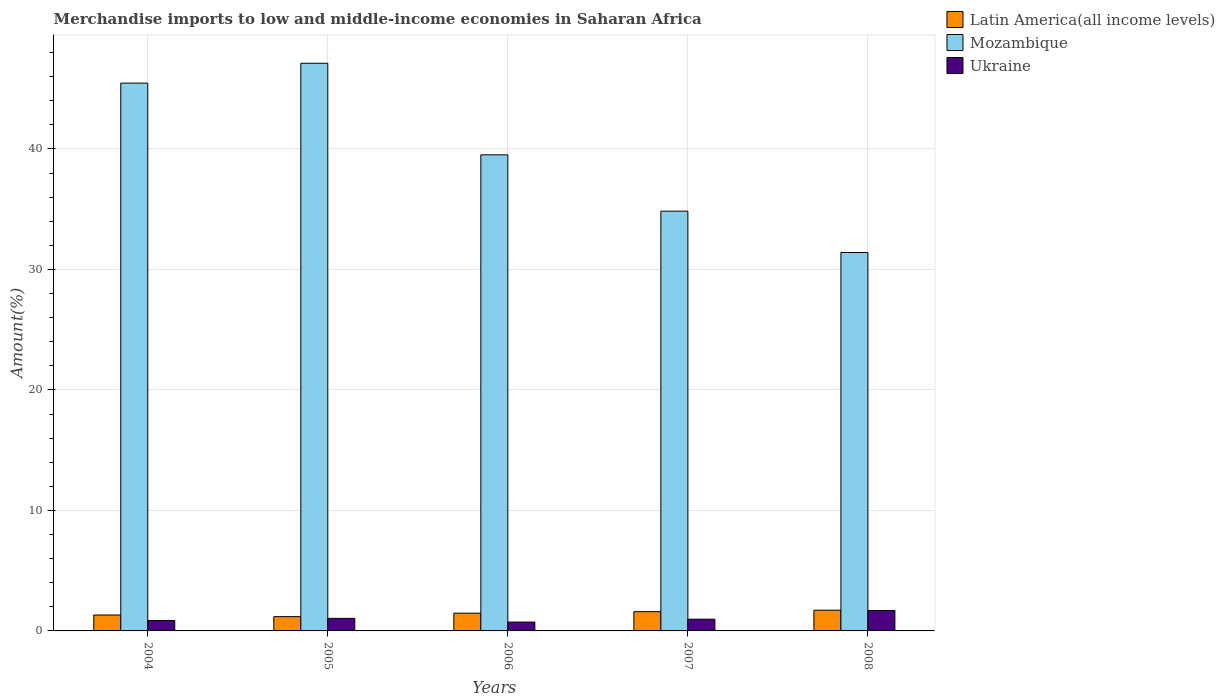How many groups of bars are there?
Provide a short and direct response. 5. Are the number of bars per tick equal to the number of legend labels?
Your answer should be very brief. Yes. Are the number of bars on each tick of the X-axis equal?
Your answer should be compact. Yes. What is the label of the 4th group of bars from the left?
Your answer should be very brief. 2007. In how many cases, is the number of bars for a given year not equal to the number of legend labels?
Your answer should be compact. 0. What is the percentage of amount earned from merchandise imports in Mozambique in 2005?
Give a very brief answer. 47.11. Across all years, what is the maximum percentage of amount earned from merchandise imports in Latin America(all income levels)?
Make the answer very short. 1.72. Across all years, what is the minimum percentage of amount earned from merchandise imports in Latin America(all income levels)?
Give a very brief answer. 1.18. In which year was the percentage of amount earned from merchandise imports in Ukraine maximum?
Give a very brief answer. 2008. In which year was the percentage of amount earned from merchandise imports in Mozambique minimum?
Offer a very short reply. 2008. What is the total percentage of amount earned from merchandise imports in Mozambique in the graph?
Make the answer very short. 198.34. What is the difference between the percentage of amount earned from merchandise imports in Mozambique in 2006 and that in 2007?
Provide a short and direct response. 4.67. What is the difference between the percentage of amount earned from merchandise imports in Latin America(all income levels) in 2005 and the percentage of amount earned from merchandise imports in Mozambique in 2006?
Provide a short and direct response. -38.33. What is the average percentage of amount earned from merchandise imports in Ukraine per year?
Provide a short and direct response. 1.06. In the year 2007, what is the difference between the percentage of amount earned from merchandise imports in Ukraine and percentage of amount earned from merchandise imports in Mozambique?
Give a very brief answer. -33.86. In how many years, is the percentage of amount earned from merchandise imports in Ukraine greater than 16 %?
Make the answer very short. 0. What is the ratio of the percentage of amount earned from merchandise imports in Ukraine in 2004 to that in 2006?
Offer a terse response. 1.17. Is the percentage of amount earned from merchandise imports in Ukraine in 2005 less than that in 2008?
Keep it short and to the point. Yes. What is the difference between the highest and the second highest percentage of amount earned from merchandise imports in Mozambique?
Provide a succinct answer. 1.65. What is the difference between the highest and the lowest percentage of amount earned from merchandise imports in Ukraine?
Offer a very short reply. 0.96. What does the 1st bar from the left in 2008 represents?
Give a very brief answer. Latin America(all income levels). What does the 3rd bar from the right in 2004 represents?
Keep it short and to the point. Latin America(all income levels). Is it the case that in every year, the sum of the percentage of amount earned from merchandise imports in Latin America(all income levels) and percentage of amount earned from merchandise imports in Ukraine is greater than the percentage of amount earned from merchandise imports in Mozambique?
Offer a terse response. No. How many bars are there?
Provide a succinct answer. 15. Are all the bars in the graph horizontal?
Provide a short and direct response. No. How many years are there in the graph?
Keep it short and to the point. 5. Are the values on the major ticks of Y-axis written in scientific E-notation?
Your answer should be very brief. No. Does the graph contain grids?
Make the answer very short. Yes. Where does the legend appear in the graph?
Your response must be concise. Top right. How many legend labels are there?
Offer a very short reply. 3. How are the legend labels stacked?
Provide a short and direct response. Vertical. What is the title of the graph?
Offer a very short reply. Merchandise imports to low and middle-income economies in Saharan Africa. What is the label or title of the Y-axis?
Your answer should be compact. Amount(%). What is the Amount(%) in Latin America(all income levels) in 2004?
Your answer should be compact. 1.32. What is the Amount(%) in Mozambique in 2004?
Provide a short and direct response. 45.47. What is the Amount(%) of Ukraine in 2004?
Offer a very short reply. 0.86. What is the Amount(%) of Latin America(all income levels) in 2005?
Provide a succinct answer. 1.18. What is the Amount(%) of Mozambique in 2005?
Your response must be concise. 47.11. What is the Amount(%) in Ukraine in 2005?
Provide a succinct answer. 1.04. What is the Amount(%) of Latin America(all income levels) in 2006?
Your answer should be compact. 1.47. What is the Amount(%) of Mozambique in 2006?
Make the answer very short. 39.51. What is the Amount(%) of Ukraine in 2006?
Offer a very short reply. 0.74. What is the Amount(%) of Latin America(all income levels) in 2007?
Provide a short and direct response. 1.6. What is the Amount(%) in Mozambique in 2007?
Give a very brief answer. 34.84. What is the Amount(%) of Ukraine in 2007?
Make the answer very short. 0.97. What is the Amount(%) in Latin America(all income levels) in 2008?
Your answer should be very brief. 1.72. What is the Amount(%) of Mozambique in 2008?
Your answer should be compact. 31.41. What is the Amount(%) in Ukraine in 2008?
Give a very brief answer. 1.7. Across all years, what is the maximum Amount(%) of Latin America(all income levels)?
Provide a succinct answer. 1.72. Across all years, what is the maximum Amount(%) of Mozambique?
Offer a terse response. 47.11. Across all years, what is the maximum Amount(%) in Ukraine?
Ensure brevity in your answer.  1.7. Across all years, what is the minimum Amount(%) of Latin America(all income levels)?
Give a very brief answer. 1.18. Across all years, what is the minimum Amount(%) of Mozambique?
Provide a short and direct response. 31.41. Across all years, what is the minimum Amount(%) of Ukraine?
Offer a terse response. 0.74. What is the total Amount(%) of Latin America(all income levels) in the graph?
Offer a terse response. 7.3. What is the total Amount(%) of Mozambique in the graph?
Make the answer very short. 198.34. What is the total Amount(%) of Ukraine in the graph?
Offer a very short reply. 5.31. What is the difference between the Amount(%) in Latin America(all income levels) in 2004 and that in 2005?
Keep it short and to the point. 0.14. What is the difference between the Amount(%) of Mozambique in 2004 and that in 2005?
Give a very brief answer. -1.65. What is the difference between the Amount(%) in Ukraine in 2004 and that in 2005?
Your answer should be compact. -0.18. What is the difference between the Amount(%) in Latin America(all income levels) in 2004 and that in 2006?
Offer a very short reply. -0.15. What is the difference between the Amount(%) in Mozambique in 2004 and that in 2006?
Your answer should be very brief. 5.95. What is the difference between the Amount(%) in Ukraine in 2004 and that in 2006?
Give a very brief answer. 0.13. What is the difference between the Amount(%) of Latin America(all income levels) in 2004 and that in 2007?
Keep it short and to the point. -0.28. What is the difference between the Amount(%) in Mozambique in 2004 and that in 2007?
Give a very brief answer. 10.63. What is the difference between the Amount(%) of Ukraine in 2004 and that in 2007?
Keep it short and to the point. -0.11. What is the difference between the Amount(%) of Latin America(all income levels) in 2004 and that in 2008?
Provide a short and direct response. -0.4. What is the difference between the Amount(%) of Mozambique in 2004 and that in 2008?
Provide a succinct answer. 14.06. What is the difference between the Amount(%) of Ukraine in 2004 and that in 2008?
Offer a very short reply. -0.83. What is the difference between the Amount(%) in Latin America(all income levels) in 2005 and that in 2006?
Ensure brevity in your answer.  -0.29. What is the difference between the Amount(%) of Mozambique in 2005 and that in 2006?
Offer a terse response. 7.6. What is the difference between the Amount(%) in Ukraine in 2005 and that in 2006?
Offer a terse response. 0.31. What is the difference between the Amount(%) of Latin America(all income levels) in 2005 and that in 2007?
Your answer should be very brief. -0.41. What is the difference between the Amount(%) in Mozambique in 2005 and that in 2007?
Keep it short and to the point. 12.27. What is the difference between the Amount(%) of Ukraine in 2005 and that in 2007?
Keep it short and to the point. 0.07. What is the difference between the Amount(%) of Latin America(all income levels) in 2005 and that in 2008?
Provide a succinct answer. -0.53. What is the difference between the Amount(%) of Mozambique in 2005 and that in 2008?
Make the answer very short. 15.71. What is the difference between the Amount(%) in Ukraine in 2005 and that in 2008?
Your answer should be very brief. -0.65. What is the difference between the Amount(%) of Latin America(all income levels) in 2006 and that in 2007?
Offer a terse response. -0.12. What is the difference between the Amount(%) in Mozambique in 2006 and that in 2007?
Your answer should be compact. 4.67. What is the difference between the Amount(%) of Ukraine in 2006 and that in 2007?
Offer a terse response. -0.24. What is the difference between the Amount(%) of Latin America(all income levels) in 2006 and that in 2008?
Provide a succinct answer. -0.24. What is the difference between the Amount(%) of Mozambique in 2006 and that in 2008?
Ensure brevity in your answer.  8.11. What is the difference between the Amount(%) in Ukraine in 2006 and that in 2008?
Offer a very short reply. -0.96. What is the difference between the Amount(%) of Latin America(all income levels) in 2007 and that in 2008?
Your answer should be very brief. -0.12. What is the difference between the Amount(%) in Mozambique in 2007 and that in 2008?
Your answer should be very brief. 3.43. What is the difference between the Amount(%) of Ukraine in 2007 and that in 2008?
Offer a very short reply. -0.72. What is the difference between the Amount(%) of Latin America(all income levels) in 2004 and the Amount(%) of Mozambique in 2005?
Your answer should be compact. -45.79. What is the difference between the Amount(%) of Latin America(all income levels) in 2004 and the Amount(%) of Ukraine in 2005?
Ensure brevity in your answer.  0.28. What is the difference between the Amount(%) of Mozambique in 2004 and the Amount(%) of Ukraine in 2005?
Provide a short and direct response. 44.42. What is the difference between the Amount(%) of Latin America(all income levels) in 2004 and the Amount(%) of Mozambique in 2006?
Your answer should be compact. -38.19. What is the difference between the Amount(%) of Latin America(all income levels) in 2004 and the Amount(%) of Ukraine in 2006?
Your answer should be very brief. 0.59. What is the difference between the Amount(%) of Mozambique in 2004 and the Amount(%) of Ukraine in 2006?
Offer a terse response. 44.73. What is the difference between the Amount(%) of Latin America(all income levels) in 2004 and the Amount(%) of Mozambique in 2007?
Make the answer very short. -33.52. What is the difference between the Amount(%) of Latin America(all income levels) in 2004 and the Amount(%) of Ukraine in 2007?
Offer a terse response. 0.35. What is the difference between the Amount(%) in Mozambique in 2004 and the Amount(%) in Ukraine in 2007?
Ensure brevity in your answer.  44.49. What is the difference between the Amount(%) of Latin America(all income levels) in 2004 and the Amount(%) of Mozambique in 2008?
Your answer should be compact. -30.08. What is the difference between the Amount(%) in Latin America(all income levels) in 2004 and the Amount(%) in Ukraine in 2008?
Your answer should be compact. -0.37. What is the difference between the Amount(%) in Mozambique in 2004 and the Amount(%) in Ukraine in 2008?
Your response must be concise. 43.77. What is the difference between the Amount(%) in Latin America(all income levels) in 2005 and the Amount(%) in Mozambique in 2006?
Make the answer very short. -38.33. What is the difference between the Amount(%) of Latin America(all income levels) in 2005 and the Amount(%) of Ukraine in 2006?
Make the answer very short. 0.45. What is the difference between the Amount(%) of Mozambique in 2005 and the Amount(%) of Ukraine in 2006?
Offer a terse response. 46.38. What is the difference between the Amount(%) in Latin America(all income levels) in 2005 and the Amount(%) in Mozambique in 2007?
Offer a terse response. -33.65. What is the difference between the Amount(%) of Latin America(all income levels) in 2005 and the Amount(%) of Ukraine in 2007?
Provide a short and direct response. 0.21. What is the difference between the Amount(%) of Mozambique in 2005 and the Amount(%) of Ukraine in 2007?
Provide a succinct answer. 46.14. What is the difference between the Amount(%) in Latin America(all income levels) in 2005 and the Amount(%) in Mozambique in 2008?
Your answer should be very brief. -30.22. What is the difference between the Amount(%) in Latin America(all income levels) in 2005 and the Amount(%) in Ukraine in 2008?
Give a very brief answer. -0.51. What is the difference between the Amount(%) of Mozambique in 2005 and the Amount(%) of Ukraine in 2008?
Your answer should be compact. 45.42. What is the difference between the Amount(%) of Latin America(all income levels) in 2006 and the Amount(%) of Mozambique in 2007?
Keep it short and to the point. -33.36. What is the difference between the Amount(%) of Latin America(all income levels) in 2006 and the Amount(%) of Ukraine in 2007?
Keep it short and to the point. 0.5. What is the difference between the Amount(%) of Mozambique in 2006 and the Amount(%) of Ukraine in 2007?
Give a very brief answer. 38.54. What is the difference between the Amount(%) of Latin America(all income levels) in 2006 and the Amount(%) of Mozambique in 2008?
Your answer should be compact. -29.93. What is the difference between the Amount(%) in Latin America(all income levels) in 2006 and the Amount(%) in Ukraine in 2008?
Make the answer very short. -0.22. What is the difference between the Amount(%) in Mozambique in 2006 and the Amount(%) in Ukraine in 2008?
Ensure brevity in your answer.  37.82. What is the difference between the Amount(%) in Latin America(all income levels) in 2007 and the Amount(%) in Mozambique in 2008?
Your answer should be compact. -29.81. What is the difference between the Amount(%) in Latin America(all income levels) in 2007 and the Amount(%) in Ukraine in 2008?
Offer a terse response. -0.1. What is the difference between the Amount(%) in Mozambique in 2007 and the Amount(%) in Ukraine in 2008?
Provide a succinct answer. 33.14. What is the average Amount(%) of Latin America(all income levels) per year?
Your response must be concise. 1.46. What is the average Amount(%) of Mozambique per year?
Your answer should be very brief. 39.67. What is the average Amount(%) of Ukraine per year?
Provide a short and direct response. 1.06. In the year 2004, what is the difference between the Amount(%) in Latin America(all income levels) and Amount(%) in Mozambique?
Your answer should be very brief. -44.15. In the year 2004, what is the difference between the Amount(%) of Latin America(all income levels) and Amount(%) of Ukraine?
Give a very brief answer. 0.46. In the year 2004, what is the difference between the Amount(%) of Mozambique and Amount(%) of Ukraine?
Your answer should be very brief. 44.6. In the year 2005, what is the difference between the Amount(%) of Latin America(all income levels) and Amount(%) of Mozambique?
Provide a succinct answer. -45.93. In the year 2005, what is the difference between the Amount(%) in Latin America(all income levels) and Amount(%) in Ukraine?
Keep it short and to the point. 0.14. In the year 2005, what is the difference between the Amount(%) in Mozambique and Amount(%) in Ukraine?
Ensure brevity in your answer.  46.07. In the year 2006, what is the difference between the Amount(%) of Latin America(all income levels) and Amount(%) of Mozambique?
Give a very brief answer. -38.04. In the year 2006, what is the difference between the Amount(%) of Latin America(all income levels) and Amount(%) of Ukraine?
Your response must be concise. 0.74. In the year 2006, what is the difference between the Amount(%) of Mozambique and Amount(%) of Ukraine?
Provide a succinct answer. 38.78. In the year 2007, what is the difference between the Amount(%) of Latin America(all income levels) and Amount(%) of Mozambique?
Provide a short and direct response. -33.24. In the year 2007, what is the difference between the Amount(%) of Latin America(all income levels) and Amount(%) of Ukraine?
Offer a very short reply. 0.62. In the year 2007, what is the difference between the Amount(%) of Mozambique and Amount(%) of Ukraine?
Your answer should be compact. 33.86. In the year 2008, what is the difference between the Amount(%) of Latin America(all income levels) and Amount(%) of Mozambique?
Your response must be concise. -29.69. In the year 2008, what is the difference between the Amount(%) of Latin America(all income levels) and Amount(%) of Ukraine?
Keep it short and to the point. 0.02. In the year 2008, what is the difference between the Amount(%) of Mozambique and Amount(%) of Ukraine?
Make the answer very short. 29.71. What is the ratio of the Amount(%) of Latin America(all income levels) in 2004 to that in 2005?
Provide a short and direct response. 1.12. What is the ratio of the Amount(%) in Mozambique in 2004 to that in 2005?
Offer a terse response. 0.97. What is the ratio of the Amount(%) in Ukraine in 2004 to that in 2005?
Your answer should be compact. 0.83. What is the ratio of the Amount(%) in Latin America(all income levels) in 2004 to that in 2006?
Give a very brief answer. 0.9. What is the ratio of the Amount(%) in Mozambique in 2004 to that in 2006?
Give a very brief answer. 1.15. What is the ratio of the Amount(%) in Ukraine in 2004 to that in 2006?
Ensure brevity in your answer.  1.17. What is the ratio of the Amount(%) in Latin America(all income levels) in 2004 to that in 2007?
Keep it short and to the point. 0.83. What is the ratio of the Amount(%) of Mozambique in 2004 to that in 2007?
Provide a succinct answer. 1.31. What is the ratio of the Amount(%) of Ukraine in 2004 to that in 2007?
Provide a short and direct response. 0.89. What is the ratio of the Amount(%) in Latin America(all income levels) in 2004 to that in 2008?
Offer a terse response. 0.77. What is the ratio of the Amount(%) of Mozambique in 2004 to that in 2008?
Make the answer very short. 1.45. What is the ratio of the Amount(%) in Ukraine in 2004 to that in 2008?
Offer a very short reply. 0.51. What is the ratio of the Amount(%) in Latin America(all income levels) in 2005 to that in 2006?
Make the answer very short. 0.8. What is the ratio of the Amount(%) in Mozambique in 2005 to that in 2006?
Your answer should be very brief. 1.19. What is the ratio of the Amount(%) in Ukraine in 2005 to that in 2006?
Keep it short and to the point. 1.42. What is the ratio of the Amount(%) of Latin America(all income levels) in 2005 to that in 2007?
Provide a succinct answer. 0.74. What is the ratio of the Amount(%) of Mozambique in 2005 to that in 2007?
Give a very brief answer. 1.35. What is the ratio of the Amount(%) in Ukraine in 2005 to that in 2007?
Provide a succinct answer. 1.07. What is the ratio of the Amount(%) in Latin America(all income levels) in 2005 to that in 2008?
Provide a succinct answer. 0.69. What is the ratio of the Amount(%) in Mozambique in 2005 to that in 2008?
Offer a terse response. 1.5. What is the ratio of the Amount(%) in Ukraine in 2005 to that in 2008?
Give a very brief answer. 0.61. What is the ratio of the Amount(%) in Latin America(all income levels) in 2006 to that in 2007?
Offer a terse response. 0.92. What is the ratio of the Amount(%) in Mozambique in 2006 to that in 2007?
Keep it short and to the point. 1.13. What is the ratio of the Amount(%) in Ukraine in 2006 to that in 2007?
Provide a succinct answer. 0.76. What is the ratio of the Amount(%) in Latin America(all income levels) in 2006 to that in 2008?
Offer a terse response. 0.86. What is the ratio of the Amount(%) of Mozambique in 2006 to that in 2008?
Keep it short and to the point. 1.26. What is the ratio of the Amount(%) of Ukraine in 2006 to that in 2008?
Provide a succinct answer. 0.43. What is the ratio of the Amount(%) of Latin America(all income levels) in 2007 to that in 2008?
Ensure brevity in your answer.  0.93. What is the ratio of the Amount(%) in Mozambique in 2007 to that in 2008?
Offer a very short reply. 1.11. What is the ratio of the Amount(%) in Ukraine in 2007 to that in 2008?
Give a very brief answer. 0.57. What is the difference between the highest and the second highest Amount(%) in Latin America(all income levels)?
Provide a short and direct response. 0.12. What is the difference between the highest and the second highest Amount(%) of Mozambique?
Provide a short and direct response. 1.65. What is the difference between the highest and the second highest Amount(%) of Ukraine?
Ensure brevity in your answer.  0.65. What is the difference between the highest and the lowest Amount(%) in Latin America(all income levels)?
Your answer should be compact. 0.53. What is the difference between the highest and the lowest Amount(%) in Mozambique?
Offer a very short reply. 15.71. What is the difference between the highest and the lowest Amount(%) of Ukraine?
Offer a very short reply. 0.96. 